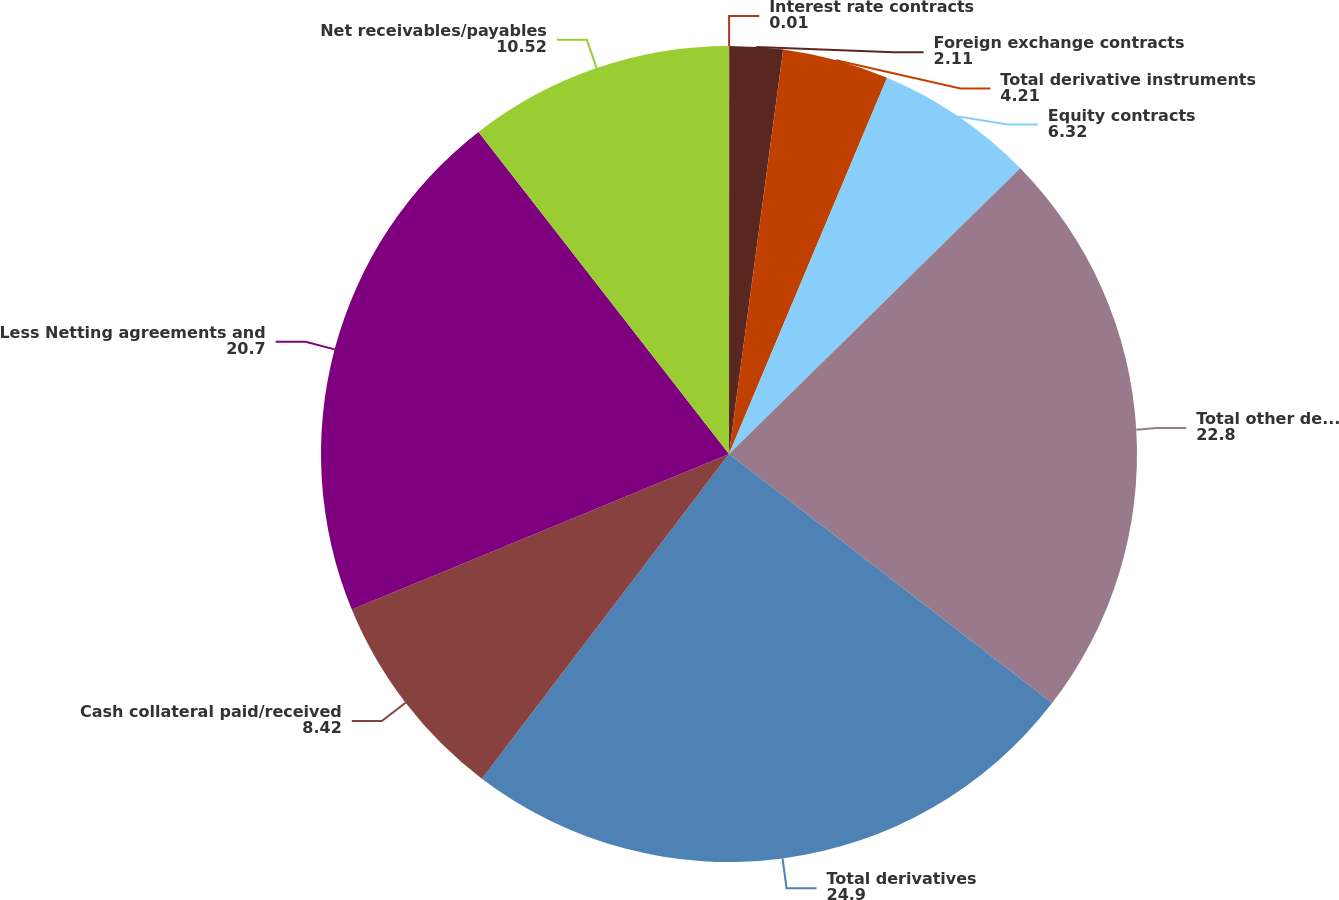Convert chart to OTSL. <chart><loc_0><loc_0><loc_500><loc_500><pie_chart><fcel>Interest rate contracts<fcel>Foreign exchange contracts<fcel>Total derivative instruments<fcel>Equity contracts<fcel>Total other derivative<fcel>Total derivatives<fcel>Cash collateral paid/received<fcel>Less Netting agreements and<fcel>Net receivables/payables<nl><fcel>0.01%<fcel>2.11%<fcel>4.21%<fcel>6.32%<fcel>22.8%<fcel>24.9%<fcel>8.42%<fcel>20.7%<fcel>10.52%<nl></chart> 